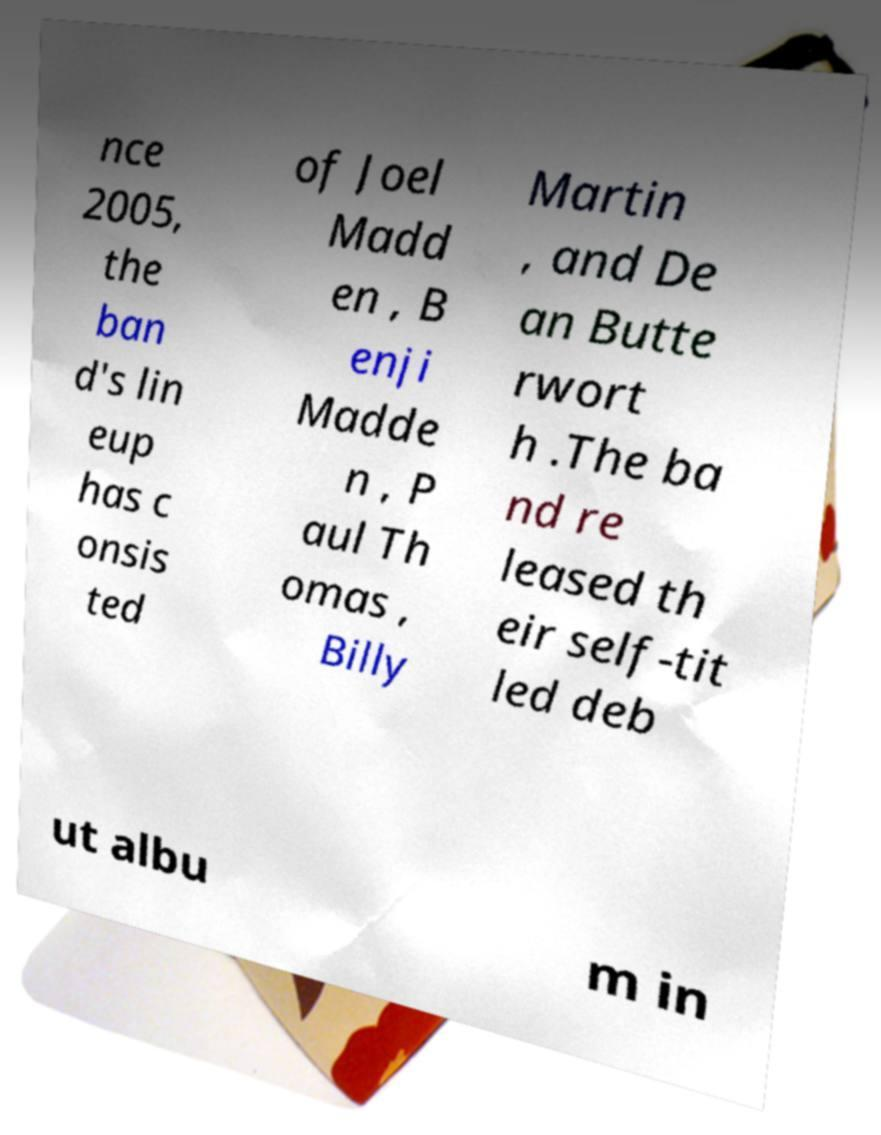Can you read and provide the text displayed in the image?This photo seems to have some interesting text. Can you extract and type it out for me? nce 2005, the ban d's lin eup has c onsis ted of Joel Madd en , B enji Madde n , P aul Th omas , Billy Martin , and De an Butte rwort h .The ba nd re leased th eir self-tit led deb ut albu m in 